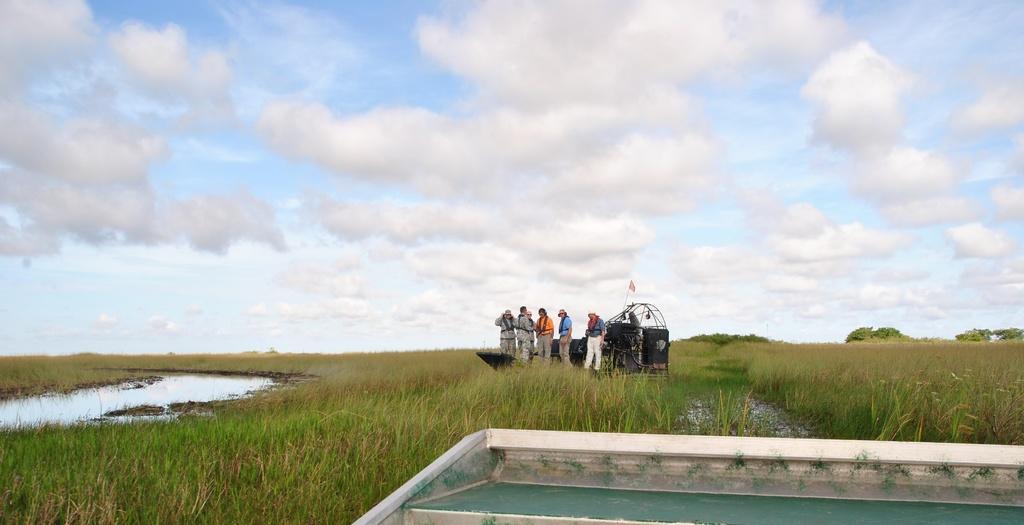In one or two sentences, can you explain what this image depicts? In this picture there are few persons and an object on a greenery ground and there is water in the left corner and the sky is cloudy. 